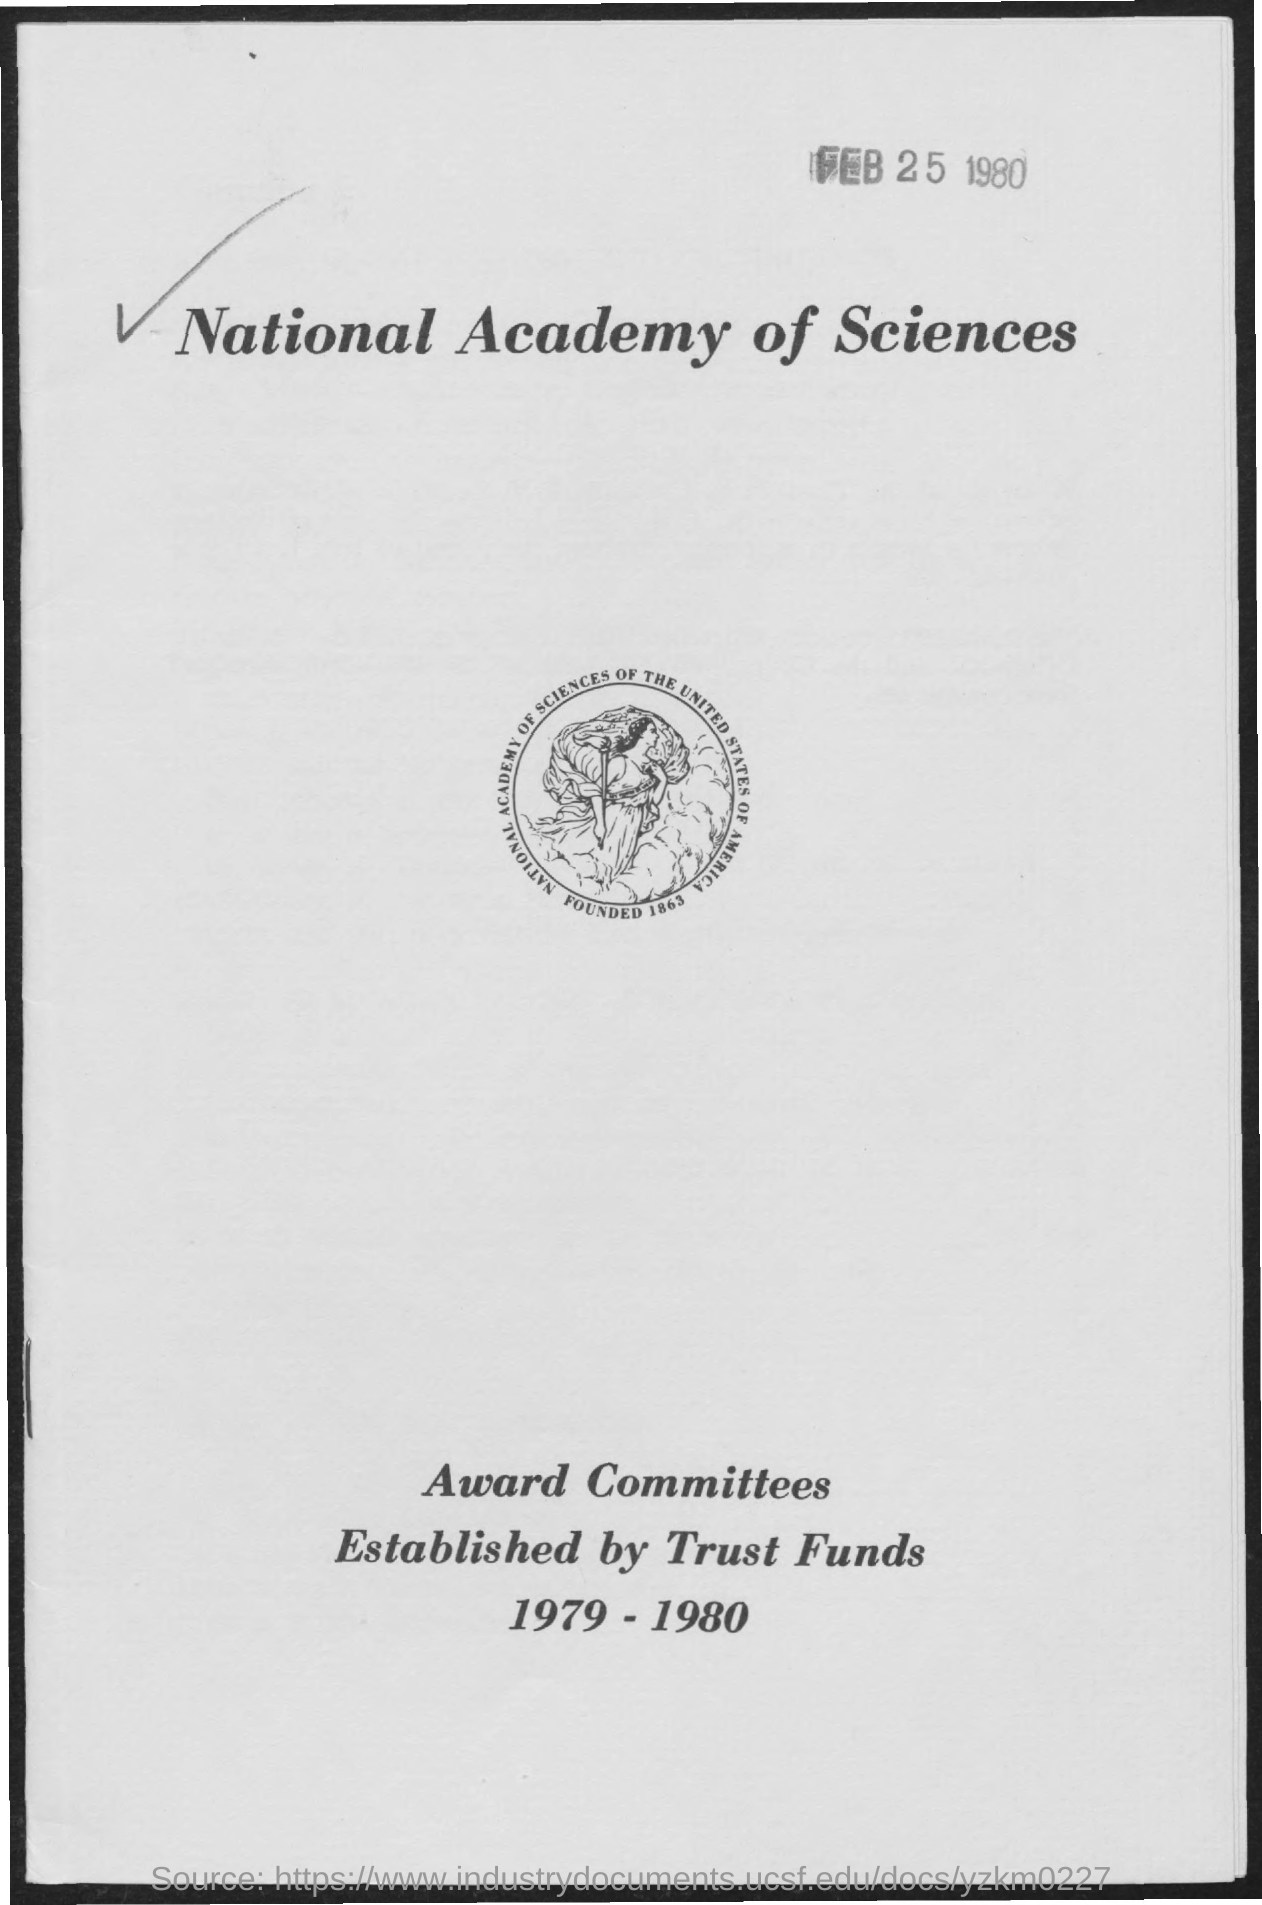In which year national academy of sciences of the united states of america is founded ?
Your answer should be compact. 1863. What is the date mentioned in the given page ?
Your answer should be compact. FEB 25 1980. 